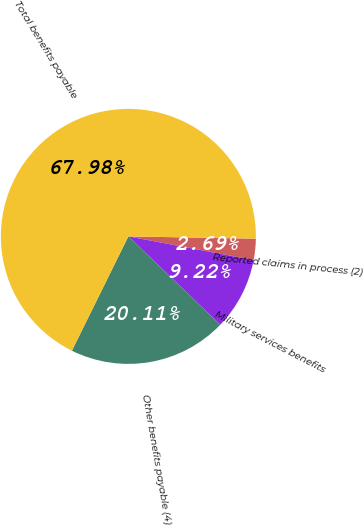<chart> <loc_0><loc_0><loc_500><loc_500><pie_chart><fcel>Reported claims in process (2)<fcel>Military services benefits<fcel>Other benefits payable (4)<fcel>Total benefits payable<nl><fcel>2.69%<fcel>9.22%<fcel>20.11%<fcel>67.99%<nl></chart> 